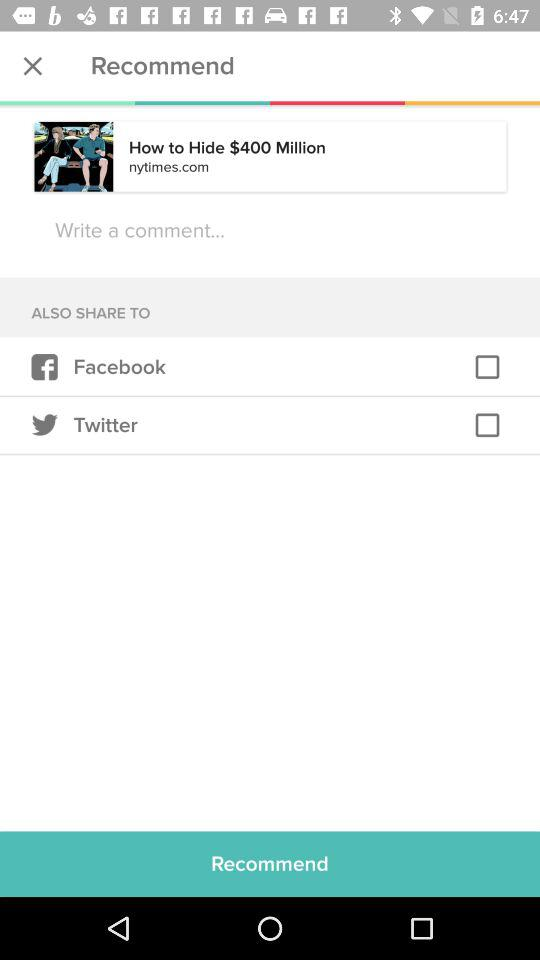How many social media platforms can I share this article to?
Answer the question using a single word or phrase. 2 